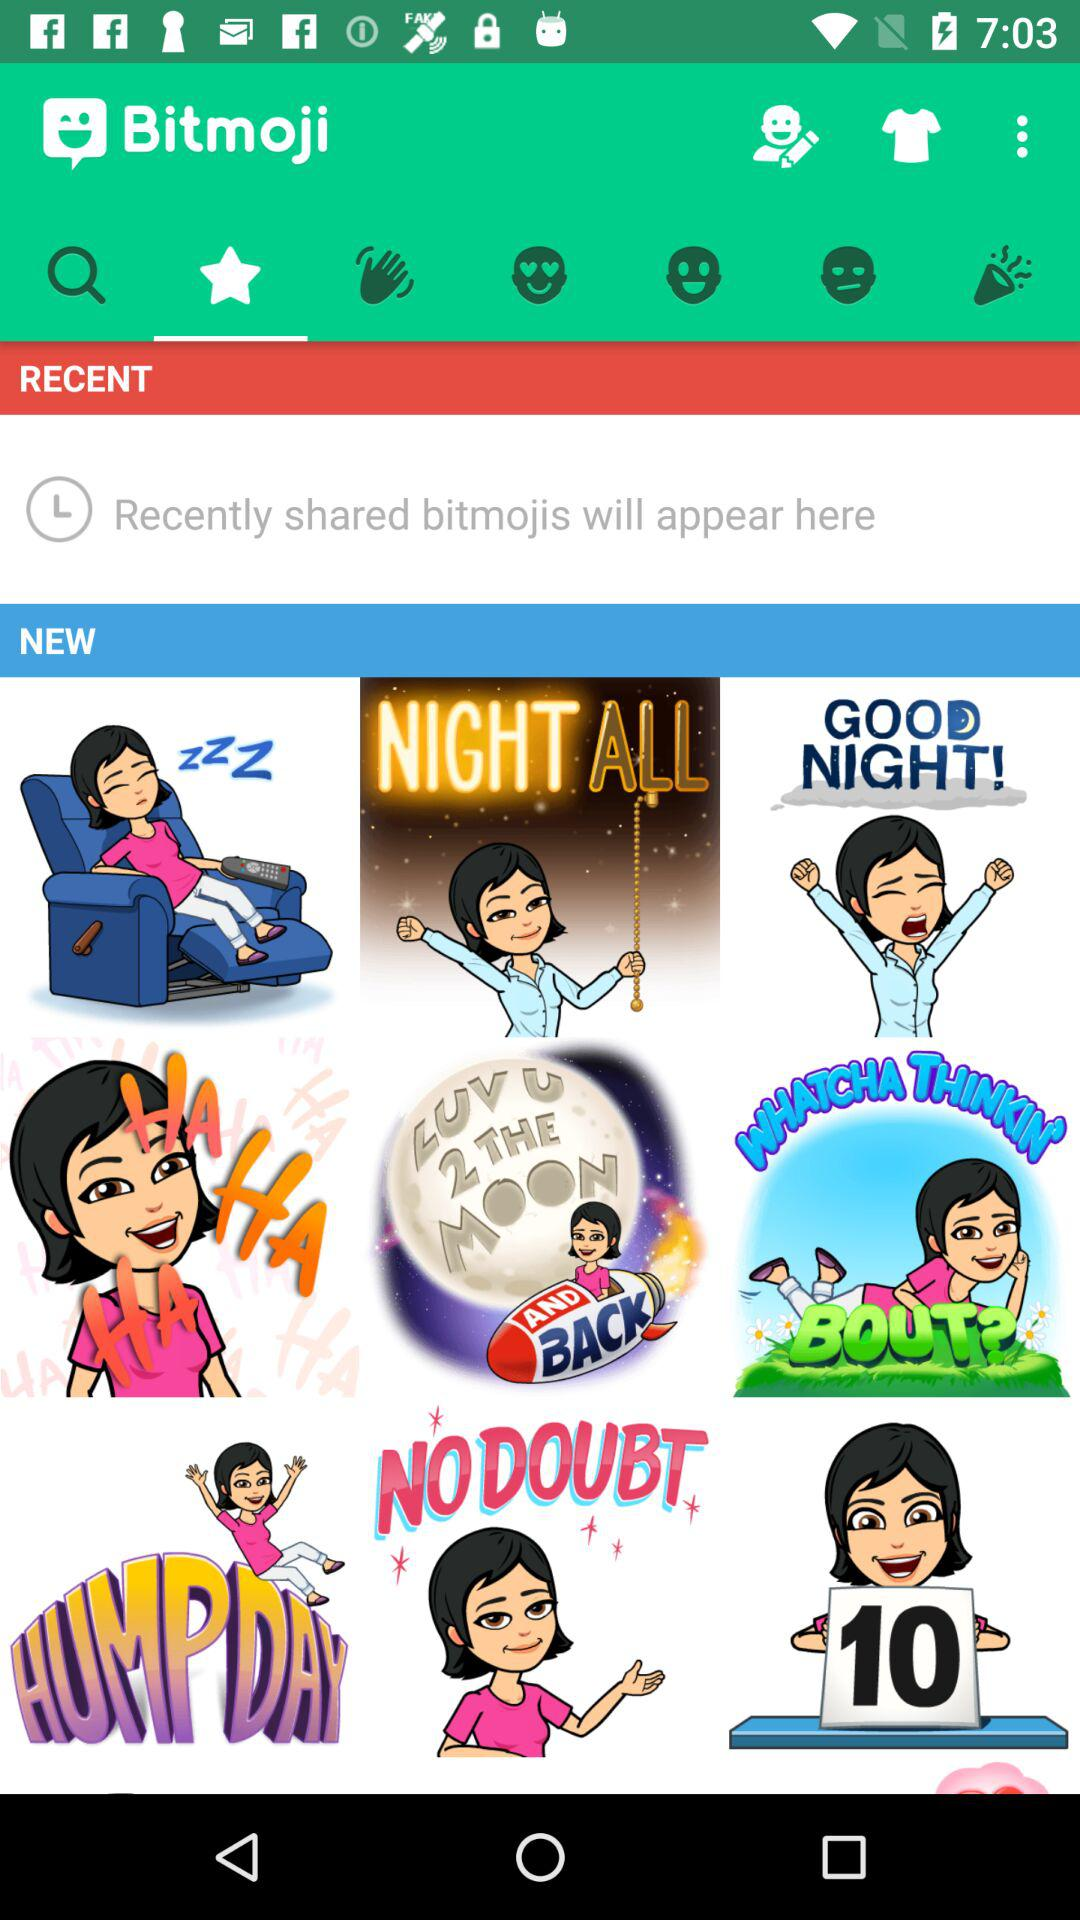Which tab is selected? The selected tab is "Favorite". 